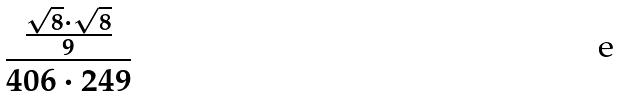Convert formula to latex. <formula><loc_0><loc_0><loc_500><loc_500>\frac { \frac { \sqrt { 8 } \cdot \sqrt { 8 } } { 9 } } { 4 0 6 \cdot 2 4 9 }</formula> 